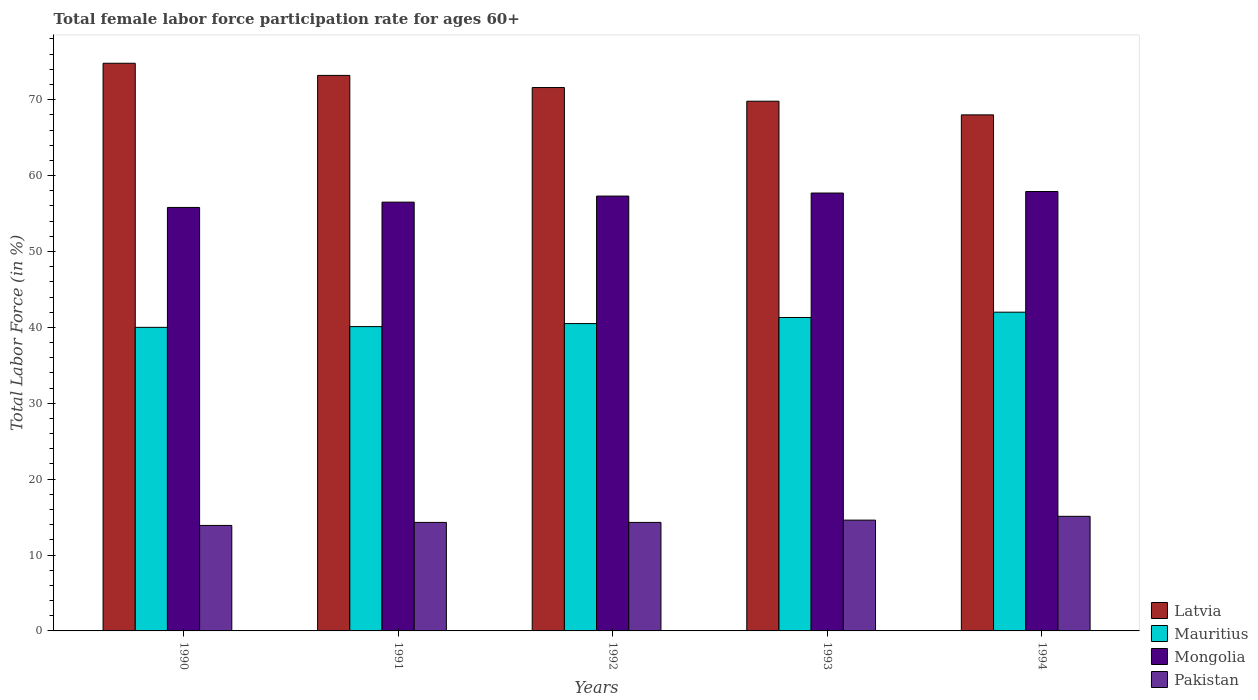How many different coloured bars are there?
Provide a short and direct response. 4. What is the female labor force participation rate in Mongolia in 1993?
Ensure brevity in your answer.  57.7. Across all years, what is the maximum female labor force participation rate in Mongolia?
Ensure brevity in your answer.  57.9. Across all years, what is the minimum female labor force participation rate in Pakistan?
Provide a short and direct response. 13.9. What is the total female labor force participation rate in Latvia in the graph?
Ensure brevity in your answer.  357.4. What is the difference between the female labor force participation rate in Mauritius in 1991 and that in 1993?
Offer a very short reply. -1.2. What is the difference between the female labor force participation rate in Pakistan in 1994 and the female labor force participation rate in Latvia in 1990?
Offer a very short reply. -59.7. What is the average female labor force participation rate in Pakistan per year?
Provide a succinct answer. 14.44. In the year 1993, what is the difference between the female labor force participation rate in Mauritius and female labor force participation rate in Mongolia?
Your answer should be very brief. -16.4. What is the ratio of the female labor force participation rate in Latvia in 1990 to that in 1991?
Provide a succinct answer. 1.02. What is the difference between the highest and the second highest female labor force participation rate in Latvia?
Your response must be concise. 1.6. What is the difference between the highest and the lowest female labor force participation rate in Pakistan?
Provide a short and direct response. 1.2. Is the sum of the female labor force participation rate in Latvia in 1990 and 1992 greater than the maximum female labor force participation rate in Pakistan across all years?
Provide a short and direct response. Yes. What does the 3rd bar from the left in 1992 represents?
Offer a terse response. Mongolia. What does the 4th bar from the right in 1994 represents?
Keep it short and to the point. Latvia. Are all the bars in the graph horizontal?
Keep it short and to the point. No. How many years are there in the graph?
Keep it short and to the point. 5. What is the difference between two consecutive major ticks on the Y-axis?
Ensure brevity in your answer.  10. Are the values on the major ticks of Y-axis written in scientific E-notation?
Keep it short and to the point. No. Does the graph contain any zero values?
Offer a terse response. No. How many legend labels are there?
Offer a very short reply. 4. What is the title of the graph?
Ensure brevity in your answer.  Total female labor force participation rate for ages 60+. Does "Nigeria" appear as one of the legend labels in the graph?
Offer a very short reply. No. What is the label or title of the X-axis?
Ensure brevity in your answer.  Years. What is the Total Labor Force (in %) in Latvia in 1990?
Give a very brief answer. 74.8. What is the Total Labor Force (in %) of Mongolia in 1990?
Offer a very short reply. 55.8. What is the Total Labor Force (in %) of Pakistan in 1990?
Ensure brevity in your answer.  13.9. What is the Total Labor Force (in %) in Latvia in 1991?
Keep it short and to the point. 73.2. What is the Total Labor Force (in %) in Mauritius in 1991?
Ensure brevity in your answer.  40.1. What is the Total Labor Force (in %) of Mongolia in 1991?
Make the answer very short. 56.5. What is the Total Labor Force (in %) of Pakistan in 1991?
Make the answer very short. 14.3. What is the Total Labor Force (in %) of Latvia in 1992?
Your response must be concise. 71.6. What is the Total Labor Force (in %) of Mauritius in 1992?
Provide a short and direct response. 40.5. What is the Total Labor Force (in %) of Mongolia in 1992?
Provide a short and direct response. 57.3. What is the Total Labor Force (in %) of Pakistan in 1992?
Give a very brief answer. 14.3. What is the Total Labor Force (in %) in Latvia in 1993?
Offer a very short reply. 69.8. What is the Total Labor Force (in %) of Mauritius in 1993?
Your response must be concise. 41.3. What is the Total Labor Force (in %) in Mongolia in 1993?
Provide a succinct answer. 57.7. What is the Total Labor Force (in %) of Pakistan in 1993?
Offer a terse response. 14.6. What is the Total Labor Force (in %) in Latvia in 1994?
Keep it short and to the point. 68. What is the Total Labor Force (in %) of Mauritius in 1994?
Ensure brevity in your answer.  42. What is the Total Labor Force (in %) of Mongolia in 1994?
Keep it short and to the point. 57.9. What is the Total Labor Force (in %) in Pakistan in 1994?
Provide a succinct answer. 15.1. Across all years, what is the maximum Total Labor Force (in %) in Latvia?
Keep it short and to the point. 74.8. Across all years, what is the maximum Total Labor Force (in %) in Mauritius?
Give a very brief answer. 42. Across all years, what is the maximum Total Labor Force (in %) in Mongolia?
Give a very brief answer. 57.9. Across all years, what is the maximum Total Labor Force (in %) of Pakistan?
Provide a short and direct response. 15.1. Across all years, what is the minimum Total Labor Force (in %) in Latvia?
Keep it short and to the point. 68. Across all years, what is the minimum Total Labor Force (in %) in Mauritius?
Provide a short and direct response. 40. Across all years, what is the minimum Total Labor Force (in %) in Mongolia?
Your response must be concise. 55.8. Across all years, what is the minimum Total Labor Force (in %) of Pakistan?
Ensure brevity in your answer.  13.9. What is the total Total Labor Force (in %) in Latvia in the graph?
Your response must be concise. 357.4. What is the total Total Labor Force (in %) in Mauritius in the graph?
Offer a very short reply. 203.9. What is the total Total Labor Force (in %) of Mongolia in the graph?
Your answer should be compact. 285.2. What is the total Total Labor Force (in %) of Pakistan in the graph?
Give a very brief answer. 72.2. What is the difference between the Total Labor Force (in %) in Mongolia in 1990 and that in 1991?
Give a very brief answer. -0.7. What is the difference between the Total Labor Force (in %) in Pakistan in 1990 and that in 1991?
Your answer should be compact. -0.4. What is the difference between the Total Labor Force (in %) of Latvia in 1990 and that in 1992?
Provide a succinct answer. 3.2. What is the difference between the Total Labor Force (in %) in Mauritius in 1990 and that in 1992?
Provide a short and direct response. -0.5. What is the difference between the Total Labor Force (in %) of Pakistan in 1990 and that in 1992?
Your answer should be very brief. -0.4. What is the difference between the Total Labor Force (in %) of Mauritius in 1990 and that in 1993?
Give a very brief answer. -1.3. What is the difference between the Total Labor Force (in %) in Latvia in 1990 and that in 1994?
Your response must be concise. 6.8. What is the difference between the Total Labor Force (in %) of Mauritius in 1990 and that in 1994?
Your response must be concise. -2. What is the difference between the Total Labor Force (in %) of Mauritius in 1991 and that in 1992?
Ensure brevity in your answer.  -0.4. What is the difference between the Total Labor Force (in %) of Pakistan in 1991 and that in 1992?
Give a very brief answer. 0. What is the difference between the Total Labor Force (in %) in Latvia in 1991 and that in 1993?
Keep it short and to the point. 3.4. What is the difference between the Total Labor Force (in %) of Mongolia in 1991 and that in 1993?
Offer a terse response. -1.2. What is the difference between the Total Labor Force (in %) of Mauritius in 1991 and that in 1994?
Give a very brief answer. -1.9. What is the difference between the Total Labor Force (in %) in Mongolia in 1991 and that in 1994?
Your answer should be very brief. -1.4. What is the difference between the Total Labor Force (in %) in Pakistan in 1991 and that in 1994?
Give a very brief answer. -0.8. What is the difference between the Total Labor Force (in %) of Latvia in 1992 and that in 1993?
Provide a succinct answer. 1.8. What is the difference between the Total Labor Force (in %) in Latvia in 1992 and that in 1994?
Make the answer very short. 3.6. What is the difference between the Total Labor Force (in %) in Mongolia in 1992 and that in 1994?
Your answer should be compact. -0.6. What is the difference between the Total Labor Force (in %) of Pakistan in 1992 and that in 1994?
Your answer should be very brief. -0.8. What is the difference between the Total Labor Force (in %) of Mongolia in 1993 and that in 1994?
Make the answer very short. -0.2. What is the difference between the Total Labor Force (in %) of Pakistan in 1993 and that in 1994?
Make the answer very short. -0.5. What is the difference between the Total Labor Force (in %) of Latvia in 1990 and the Total Labor Force (in %) of Mauritius in 1991?
Offer a very short reply. 34.7. What is the difference between the Total Labor Force (in %) in Latvia in 1990 and the Total Labor Force (in %) in Mongolia in 1991?
Offer a very short reply. 18.3. What is the difference between the Total Labor Force (in %) in Latvia in 1990 and the Total Labor Force (in %) in Pakistan in 1991?
Provide a succinct answer. 60.5. What is the difference between the Total Labor Force (in %) in Mauritius in 1990 and the Total Labor Force (in %) in Mongolia in 1991?
Keep it short and to the point. -16.5. What is the difference between the Total Labor Force (in %) of Mauritius in 1990 and the Total Labor Force (in %) of Pakistan in 1991?
Give a very brief answer. 25.7. What is the difference between the Total Labor Force (in %) of Mongolia in 1990 and the Total Labor Force (in %) of Pakistan in 1991?
Provide a succinct answer. 41.5. What is the difference between the Total Labor Force (in %) of Latvia in 1990 and the Total Labor Force (in %) of Mauritius in 1992?
Keep it short and to the point. 34.3. What is the difference between the Total Labor Force (in %) of Latvia in 1990 and the Total Labor Force (in %) of Pakistan in 1992?
Your answer should be compact. 60.5. What is the difference between the Total Labor Force (in %) in Mauritius in 1990 and the Total Labor Force (in %) in Mongolia in 1992?
Give a very brief answer. -17.3. What is the difference between the Total Labor Force (in %) of Mauritius in 1990 and the Total Labor Force (in %) of Pakistan in 1992?
Keep it short and to the point. 25.7. What is the difference between the Total Labor Force (in %) in Mongolia in 1990 and the Total Labor Force (in %) in Pakistan in 1992?
Provide a short and direct response. 41.5. What is the difference between the Total Labor Force (in %) in Latvia in 1990 and the Total Labor Force (in %) in Mauritius in 1993?
Keep it short and to the point. 33.5. What is the difference between the Total Labor Force (in %) of Latvia in 1990 and the Total Labor Force (in %) of Mongolia in 1993?
Provide a short and direct response. 17.1. What is the difference between the Total Labor Force (in %) of Latvia in 1990 and the Total Labor Force (in %) of Pakistan in 1993?
Make the answer very short. 60.2. What is the difference between the Total Labor Force (in %) of Mauritius in 1990 and the Total Labor Force (in %) of Mongolia in 1993?
Make the answer very short. -17.7. What is the difference between the Total Labor Force (in %) in Mauritius in 1990 and the Total Labor Force (in %) in Pakistan in 1993?
Offer a terse response. 25.4. What is the difference between the Total Labor Force (in %) in Mongolia in 1990 and the Total Labor Force (in %) in Pakistan in 1993?
Provide a short and direct response. 41.2. What is the difference between the Total Labor Force (in %) of Latvia in 1990 and the Total Labor Force (in %) of Mauritius in 1994?
Your answer should be compact. 32.8. What is the difference between the Total Labor Force (in %) in Latvia in 1990 and the Total Labor Force (in %) in Mongolia in 1994?
Give a very brief answer. 16.9. What is the difference between the Total Labor Force (in %) in Latvia in 1990 and the Total Labor Force (in %) in Pakistan in 1994?
Your answer should be very brief. 59.7. What is the difference between the Total Labor Force (in %) in Mauritius in 1990 and the Total Labor Force (in %) in Mongolia in 1994?
Your response must be concise. -17.9. What is the difference between the Total Labor Force (in %) of Mauritius in 1990 and the Total Labor Force (in %) of Pakistan in 1994?
Your answer should be very brief. 24.9. What is the difference between the Total Labor Force (in %) in Mongolia in 1990 and the Total Labor Force (in %) in Pakistan in 1994?
Ensure brevity in your answer.  40.7. What is the difference between the Total Labor Force (in %) in Latvia in 1991 and the Total Labor Force (in %) in Mauritius in 1992?
Your answer should be compact. 32.7. What is the difference between the Total Labor Force (in %) of Latvia in 1991 and the Total Labor Force (in %) of Pakistan in 1992?
Your answer should be very brief. 58.9. What is the difference between the Total Labor Force (in %) of Mauritius in 1991 and the Total Labor Force (in %) of Mongolia in 1992?
Your answer should be very brief. -17.2. What is the difference between the Total Labor Force (in %) of Mauritius in 1991 and the Total Labor Force (in %) of Pakistan in 1992?
Offer a very short reply. 25.8. What is the difference between the Total Labor Force (in %) in Mongolia in 1991 and the Total Labor Force (in %) in Pakistan in 1992?
Your answer should be compact. 42.2. What is the difference between the Total Labor Force (in %) of Latvia in 1991 and the Total Labor Force (in %) of Mauritius in 1993?
Your response must be concise. 31.9. What is the difference between the Total Labor Force (in %) of Latvia in 1991 and the Total Labor Force (in %) of Pakistan in 1993?
Ensure brevity in your answer.  58.6. What is the difference between the Total Labor Force (in %) of Mauritius in 1991 and the Total Labor Force (in %) of Mongolia in 1993?
Your answer should be compact. -17.6. What is the difference between the Total Labor Force (in %) in Mongolia in 1991 and the Total Labor Force (in %) in Pakistan in 1993?
Give a very brief answer. 41.9. What is the difference between the Total Labor Force (in %) of Latvia in 1991 and the Total Labor Force (in %) of Mauritius in 1994?
Make the answer very short. 31.2. What is the difference between the Total Labor Force (in %) of Latvia in 1991 and the Total Labor Force (in %) of Pakistan in 1994?
Your answer should be very brief. 58.1. What is the difference between the Total Labor Force (in %) of Mauritius in 1991 and the Total Labor Force (in %) of Mongolia in 1994?
Ensure brevity in your answer.  -17.8. What is the difference between the Total Labor Force (in %) of Mauritius in 1991 and the Total Labor Force (in %) of Pakistan in 1994?
Provide a succinct answer. 25. What is the difference between the Total Labor Force (in %) of Mongolia in 1991 and the Total Labor Force (in %) of Pakistan in 1994?
Offer a terse response. 41.4. What is the difference between the Total Labor Force (in %) of Latvia in 1992 and the Total Labor Force (in %) of Mauritius in 1993?
Offer a terse response. 30.3. What is the difference between the Total Labor Force (in %) of Latvia in 1992 and the Total Labor Force (in %) of Mongolia in 1993?
Provide a succinct answer. 13.9. What is the difference between the Total Labor Force (in %) of Mauritius in 1992 and the Total Labor Force (in %) of Mongolia in 1993?
Your answer should be very brief. -17.2. What is the difference between the Total Labor Force (in %) in Mauritius in 1992 and the Total Labor Force (in %) in Pakistan in 1993?
Your answer should be compact. 25.9. What is the difference between the Total Labor Force (in %) in Mongolia in 1992 and the Total Labor Force (in %) in Pakistan in 1993?
Provide a short and direct response. 42.7. What is the difference between the Total Labor Force (in %) of Latvia in 1992 and the Total Labor Force (in %) of Mauritius in 1994?
Offer a terse response. 29.6. What is the difference between the Total Labor Force (in %) in Latvia in 1992 and the Total Labor Force (in %) in Mongolia in 1994?
Make the answer very short. 13.7. What is the difference between the Total Labor Force (in %) in Latvia in 1992 and the Total Labor Force (in %) in Pakistan in 1994?
Give a very brief answer. 56.5. What is the difference between the Total Labor Force (in %) of Mauritius in 1992 and the Total Labor Force (in %) of Mongolia in 1994?
Provide a succinct answer. -17.4. What is the difference between the Total Labor Force (in %) in Mauritius in 1992 and the Total Labor Force (in %) in Pakistan in 1994?
Offer a terse response. 25.4. What is the difference between the Total Labor Force (in %) of Mongolia in 1992 and the Total Labor Force (in %) of Pakistan in 1994?
Keep it short and to the point. 42.2. What is the difference between the Total Labor Force (in %) of Latvia in 1993 and the Total Labor Force (in %) of Mauritius in 1994?
Offer a very short reply. 27.8. What is the difference between the Total Labor Force (in %) in Latvia in 1993 and the Total Labor Force (in %) in Pakistan in 1994?
Make the answer very short. 54.7. What is the difference between the Total Labor Force (in %) of Mauritius in 1993 and the Total Labor Force (in %) of Mongolia in 1994?
Offer a very short reply. -16.6. What is the difference between the Total Labor Force (in %) of Mauritius in 1993 and the Total Labor Force (in %) of Pakistan in 1994?
Ensure brevity in your answer.  26.2. What is the difference between the Total Labor Force (in %) in Mongolia in 1993 and the Total Labor Force (in %) in Pakistan in 1994?
Ensure brevity in your answer.  42.6. What is the average Total Labor Force (in %) in Latvia per year?
Offer a terse response. 71.48. What is the average Total Labor Force (in %) of Mauritius per year?
Your response must be concise. 40.78. What is the average Total Labor Force (in %) of Mongolia per year?
Give a very brief answer. 57.04. What is the average Total Labor Force (in %) in Pakistan per year?
Provide a short and direct response. 14.44. In the year 1990, what is the difference between the Total Labor Force (in %) in Latvia and Total Labor Force (in %) in Mauritius?
Your answer should be very brief. 34.8. In the year 1990, what is the difference between the Total Labor Force (in %) of Latvia and Total Labor Force (in %) of Pakistan?
Offer a terse response. 60.9. In the year 1990, what is the difference between the Total Labor Force (in %) in Mauritius and Total Labor Force (in %) in Mongolia?
Offer a terse response. -15.8. In the year 1990, what is the difference between the Total Labor Force (in %) in Mauritius and Total Labor Force (in %) in Pakistan?
Provide a succinct answer. 26.1. In the year 1990, what is the difference between the Total Labor Force (in %) of Mongolia and Total Labor Force (in %) of Pakistan?
Your response must be concise. 41.9. In the year 1991, what is the difference between the Total Labor Force (in %) of Latvia and Total Labor Force (in %) of Mauritius?
Keep it short and to the point. 33.1. In the year 1991, what is the difference between the Total Labor Force (in %) in Latvia and Total Labor Force (in %) in Pakistan?
Your answer should be compact. 58.9. In the year 1991, what is the difference between the Total Labor Force (in %) in Mauritius and Total Labor Force (in %) in Mongolia?
Keep it short and to the point. -16.4. In the year 1991, what is the difference between the Total Labor Force (in %) in Mauritius and Total Labor Force (in %) in Pakistan?
Your response must be concise. 25.8. In the year 1991, what is the difference between the Total Labor Force (in %) of Mongolia and Total Labor Force (in %) of Pakistan?
Your answer should be compact. 42.2. In the year 1992, what is the difference between the Total Labor Force (in %) in Latvia and Total Labor Force (in %) in Mauritius?
Your response must be concise. 31.1. In the year 1992, what is the difference between the Total Labor Force (in %) of Latvia and Total Labor Force (in %) of Pakistan?
Offer a terse response. 57.3. In the year 1992, what is the difference between the Total Labor Force (in %) in Mauritius and Total Labor Force (in %) in Mongolia?
Provide a short and direct response. -16.8. In the year 1992, what is the difference between the Total Labor Force (in %) of Mauritius and Total Labor Force (in %) of Pakistan?
Make the answer very short. 26.2. In the year 1993, what is the difference between the Total Labor Force (in %) in Latvia and Total Labor Force (in %) in Mauritius?
Offer a terse response. 28.5. In the year 1993, what is the difference between the Total Labor Force (in %) in Latvia and Total Labor Force (in %) in Pakistan?
Make the answer very short. 55.2. In the year 1993, what is the difference between the Total Labor Force (in %) in Mauritius and Total Labor Force (in %) in Mongolia?
Ensure brevity in your answer.  -16.4. In the year 1993, what is the difference between the Total Labor Force (in %) of Mauritius and Total Labor Force (in %) of Pakistan?
Ensure brevity in your answer.  26.7. In the year 1993, what is the difference between the Total Labor Force (in %) in Mongolia and Total Labor Force (in %) in Pakistan?
Provide a succinct answer. 43.1. In the year 1994, what is the difference between the Total Labor Force (in %) in Latvia and Total Labor Force (in %) in Mongolia?
Your response must be concise. 10.1. In the year 1994, what is the difference between the Total Labor Force (in %) in Latvia and Total Labor Force (in %) in Pakistan?
Provide a short and direct response. 52.9. In the year 1994, what is the difference between the Total Labor Force (in %) of Mauritius and Total Labor Force (in %) of Mongolia?
Give a very brief answer. -15.9. In the year 1994, what is the difference between the Total Labor Force (in %) of Mauritius and Total Labor Force (in %) of Pakistan?
Give a very brief answer. 26.9. In the year 1994, what is the difference between the Total Labor Force (in %) of Mongolia and Total Labor Force (in %) of Pakistan?
Your answer should be very brief. 42.8. What is the ratio of the Total Labor Force (in %) of Latvia in 1990 to that in 1991?
Your answer should be very brief. 1.02. What is the ratio of the Total Labor Force (in %) of Mongolia in 1990 to that in 1991?
Your answer should be compact. 0.99. What is the ratio of the Total Labor Force (in %) in Latvia in 1990 to that in 1992?
Offer a terse response. 1.04. What is the ratio of the Total Labor Force (in %) in Mongolia in 1990 to that in 1992?
Your answer should be very brief. 0.97. What is the ratio of the Total Labor Force (in %) of Pakistan in 1990 to that in 1992?
Your answer should be compact. 0.97. What is the ratio of the Total Labor Force (in %) of Latvia in 1990 to that in 1993?
Keep it short and to the point. 1.07. What is the ratio of the Total Labor Force (in %) in Mauritius in 1990 to that in 1993?
Your answer should be very brief. 0.97. What is the ratio of the Total Labor Force (in %) of Mongolia in 1990 to that in 1993?
Offer a terse response. 0.97. What is the ratio of the Total Labor Force (in %) of Pakistan in 1990 to that in 1993?
Offer a terse response. 0.95. What is the ratio of the Total Labor Force (in %) of Mauritius in 1990 to that in 1994?
Your response must be concise. 0.95. What is the ratio of the Total Labor Force (in %) of Mongolia in 1990 to that in 1994?
Your answer should be very brief. 0.96. What is the ratio of the Total Labor Force (in %) in Pakistan in 1990 to that in 1994?
Make the answer very short. 0.92. What is the ratio of the Total Labor Force (in %) in Latvia in 1991 to that in 1992?
Ensure brevity in your answer.  1.02. What is the ratio of the Total Labor Force (in %) in Latvia in 1991 to that in 1993?
Your response must be concise. 1.05. What is the ratio of the Total Labor Force (in %) in Mauritius in 1991 to that in 1993?
Your response must be concise. 0.97. What is the ratio of the Total Labor Force (in %) of Mongolia in 1991 to that in 1993?
Keep it short and to the point. 0.98. What is the ratio of the Total Labor Force (in %) of Pakistan in 1991 to that in 1993?
Your response must be concise. 0.98. What is the ratio of the Total Labor Force (in %) in Latvia in 1991 to that in 1994?
Give a very brief answer. 1.08. What is the ratio of the Total Labor Force (in %) of Mauritius in 1991 to that in 1994?
Ensure brevity in your answer.  0.95. What is the ratio of the Total Labor Force (in %) of Mongolia in 1991 to that in 1994?
Keep it short and to the point. 0.98. What is the ratio of the Total Labor Force (in %) of Pakistan in 1991 to that in 1994?
Your answer should be very brief. 0.95. What is the ratio of the Total Labor Force (in %) of Latvia in 1992 to that in 1993?
Ensure brevity in your answer.  1.03. What is the ratio of the Total Labor Force (in %) of Mauritius in 1992 to that in 1993?
Offer a very short reply. 0.98. What is the ratio of the Total Labor Force (in %) in Mongolia in 1992 to that in 1993?
Offer a terse response. 0.99. What is the ratio of the Total Labor Force (in %) in Pakistan in 1992 to that in 1993?
Your answer should be compact. 0.98. What is the ratio of the Total Labor Force (in %) of Latvia in 1992 to that in 1994?
Provide a succinct answer. 1.05. What is the ratio of the Total Labor Force (in %) in Mongolia in 1992 to that in 1994?
Offer a terse response. 0.99. What is the ratio of the Total Labor Force (in %) of Pakistan in 1992 to that in 1994?
Make the answer very short. 0.95. What is the ratio of the Total Labor Force (in %) in Latvia in 1993 to that in 1994?
Provide a succinct answer. 1.03. What is the ratio of the Total Labor Force (in %) of Mauritius in 1993 to that in 1994?
Keep it short and to the point. 0.98. What is the ratio of the Total Labor Force (in %) of Mongolia in 1993 to that in 1994?
Offer a very short reply. 1. What is the ratio of the Total Labor Force (in %) of Pakistan in 1993 to that in 1994?
Your answer should be compact. 0.97. What is the difference between the highest and the second highest Total Labor Force (in %) of Latvia?
Make the answer very short. 1.6. What is the difference between the highest and the second highest Total Labor Force (in %) of Mauritius?
Provide a succinct answer. 0.7. What is the difference between the highest and the lowest Total Labor Force (in %) of Latvia?
Make the answer very short. 6.8. What is the difference between the highest and the lowest Total Labor Force (in %) in Mauritius?
Keep it short and to the point. 2. What is the difference between the highest and the lowest Total Labor Force (in %) of Mongolia?
Your response must be concise. 2.1. What is the difference between the highest and the lowest Total Labor Force (in %) of Pakistan?
Provide a succinct answer. 1.2. 